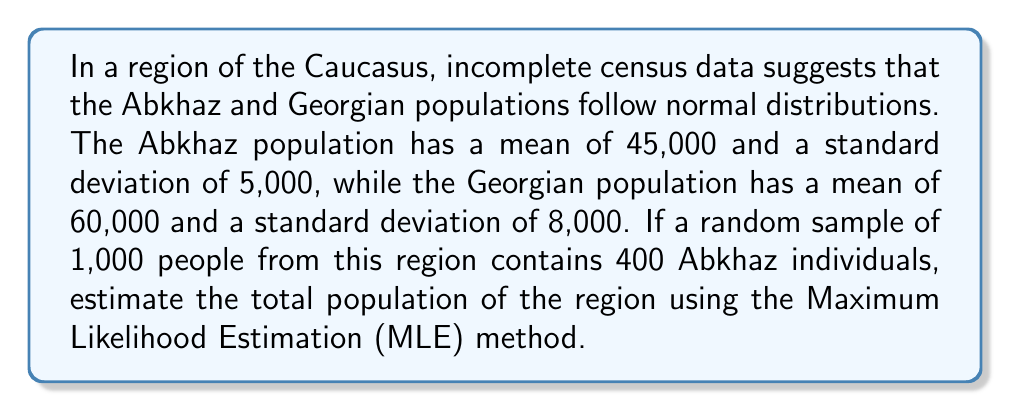What is the answer to this math problem? To solve this inverse problem using the Maximum Likelihood Estimation method, we'll follow these steps:

1) Let's define our variables:
   $p_A$ = proportion of Abkhaz in the population
   $p_G$ = proportion of Georgians in the population
   $N$ = total population

2) From the sample, we know:
   $\frac{400}{1000} = 0.4 = $ estimated $p_A$
   $1 - 0.4 = 0.6 = $ estimated $p_G$

3) The likelihood function for this binomial distribution is:
   $$L(p_A) = \binom{1000}{400} p_A^{400} (1-p_A)^{600}$$

4) The MLE estimate for $p_A$ is the sample proportion, 0.4.

5) Now, we can use the normal distribution properties:
   For Abkhaz: $0.4N \sim N(45000, 5000^2)$
   For Georgians: $0.6N \sim N(60000, 8000^2)$

6) This gives us two equations:
   $0.4N = 45000$
   $0.6N = 60000$

7) Solving either equation:
   $N = \frac{45000}{0.4} = \frac{60000}{0.6} = 112500$

8) We can verify this result satisfies both equations:
   $0.4 * 112500 = 45000$
   $0.6 * 112500 = 67500$

Therefore, the MLE estimate for the total population is 112,500.
Answer: 112,500 